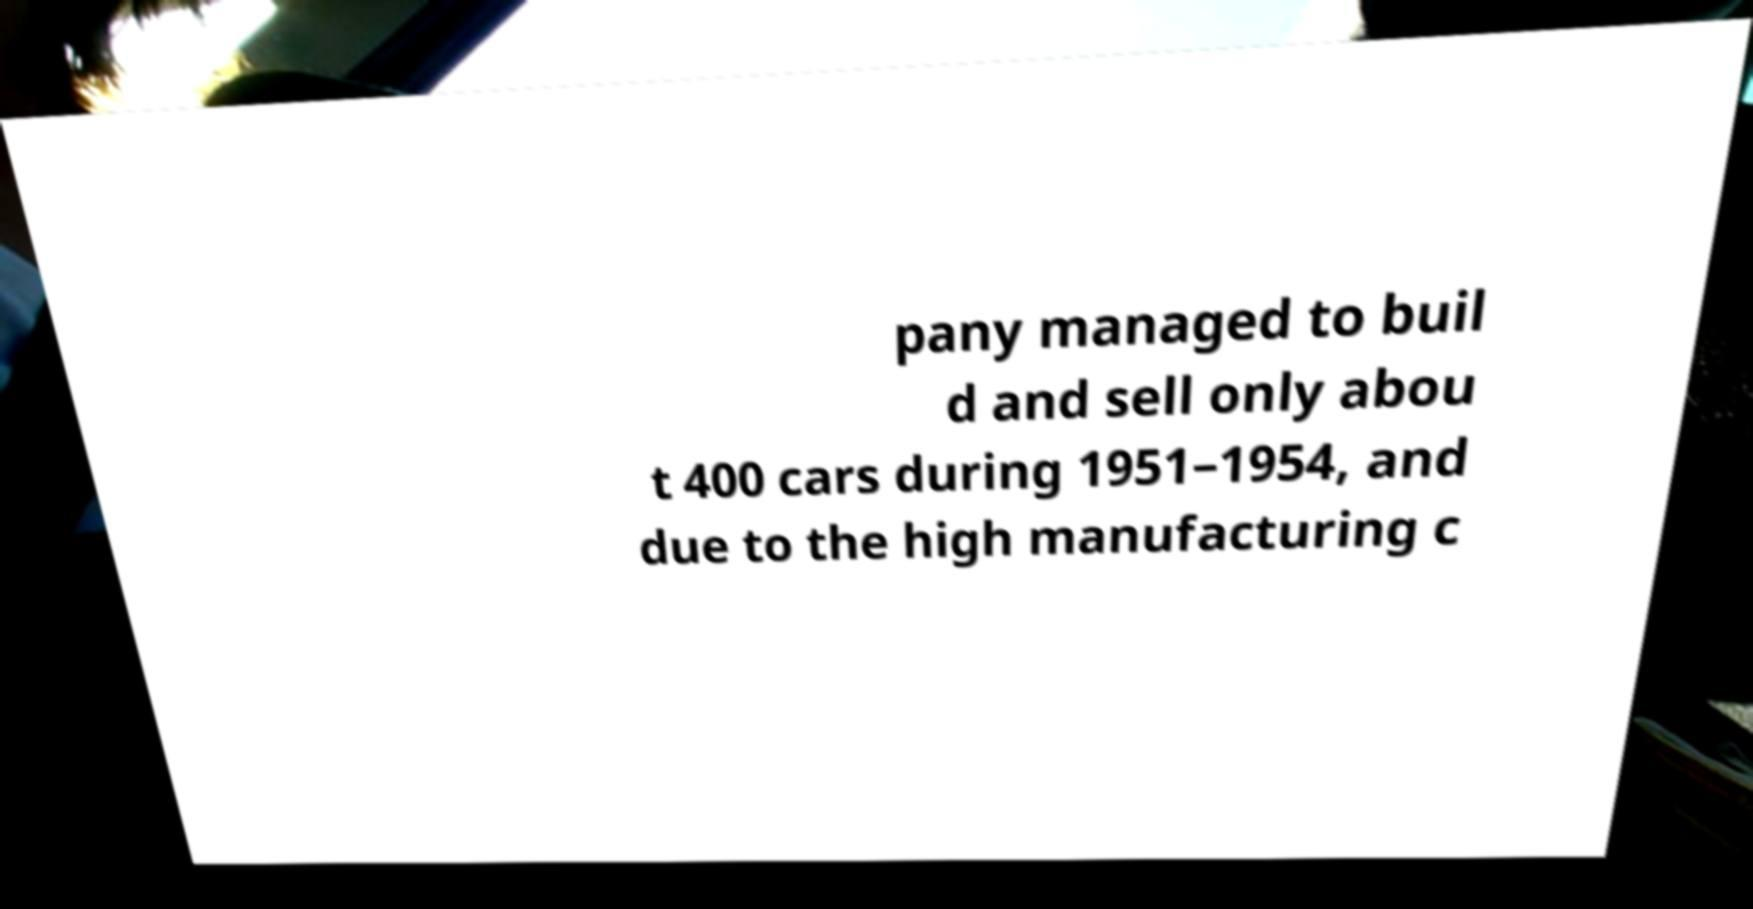For documentation purposes, I need the text within this image transcribed. Could you provide that? pany managed to buil d and sell only abou t 400 cars during 1951–1954, and due to the high manufacturing c 